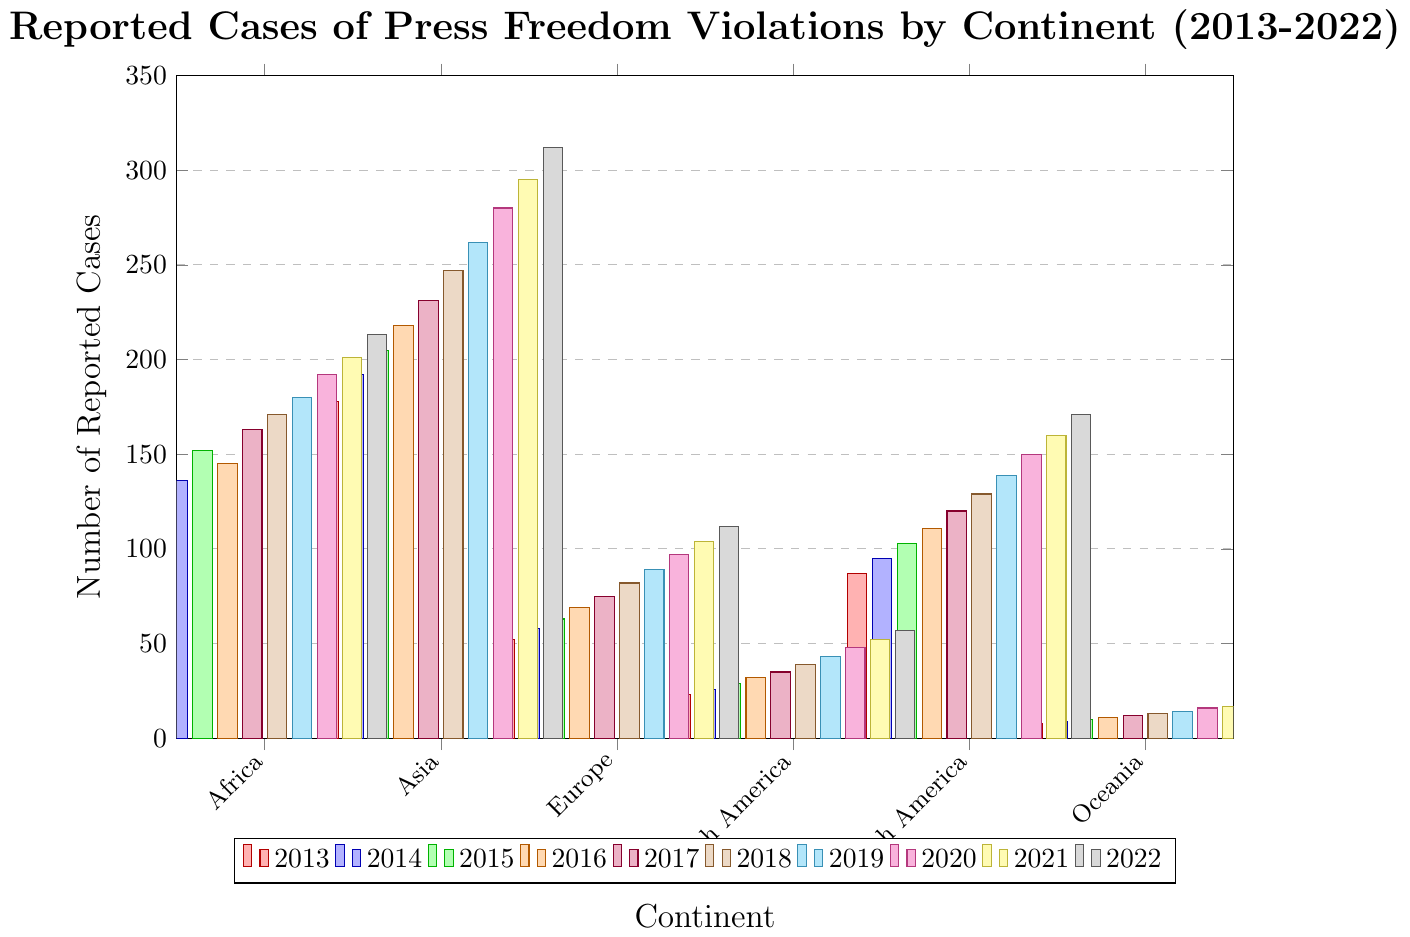Which continent reported the highest number of press freedom violations in 2022? By examining the height of the bars representing each continent in 2022, we see that Asia has the tallest bar, indicating it reported the highest number of press freedom violations.
Answer: Asia Which continent had the lowest increase in press freedom violations from 2013 to 2022? To identify the continent with the smallest increase, compare the starting and ending values for each continent and calculate the difference. Oceania increased by 11 cases (19 - 8), which is the smallest increase.
Answer: Oceania What was the total number of reported press freedom violations in Europe from 2013 to 2022? Sum up the reported cases for Europe from each year: 52 + 58 + 63 + 69 + 75 + 82 + 89 + 97 + 104 + 112 = 801.
Answer: 801 In which year did South America report more cases than North America for the first time? Compare the annual reported cases of South America and North America. In 2013, South America had 87 cases while North America had 23, so South America had more cases all along.
Answer: 2013 Between 2016 and 2017, which continent saw the largest numerical increase in reported press freedom violations? Calculate the difference for each continent between 2016 and 2017: Africa (163-145=18), Asia (231-218=13), Europe (75-69=6), North America (35-32=3), South America (120-111=9), Oceania (12-11=1). Africa had the largest increase.
Answer: Africa What is the average annual increase in press freedom violations in Asia over the decade? To find the average increase, calculate the differences for each consecutive year, sum them, and divide by the number of years: (192-178)+(205-192)+(218-205)+(231-218)+(247-231)+(262-247)+(280-262)+(295-280)+(312-295) = 19+13+13+13+16+15+18+15+17 = 139. Average increase = 139/9 ≈ 15.44.
Answer: 15.44 How many reported press freedom violations were noted worldwide in 2020? Sum up the reported cases for each continent in 2020: 192 + 280 + 97 + 48 + 150 + 16 = 783.
Answer: 783 Which continent showed a consistent increase in reported violations every year from 2013 to 2022? By inspecting the bars for each continent year by year, Asia shows a consistent increase in reported cases annually without any drops.
Answer: Asia Which continent had the greatest percent increase in reported cases from 2013-2022? Calculate the percent increase for each continent: Africa: ((213-124)/124) * 100 ≈ 71.77%, Asia: ((312-178)/178) * 100 ≈ 75.28%, Europe: ((112-52)/52) * 100 ≈ 115.38%, North America: ((57-23)/23) * 100 ≈ 147.83%, South America: ((171-87)/87) * 100 ≈ 96.55%, Oceania: ((19-8)/8) * 100 ≈ 137.50%. North America had the greatest percent increase.
Answer: North America 